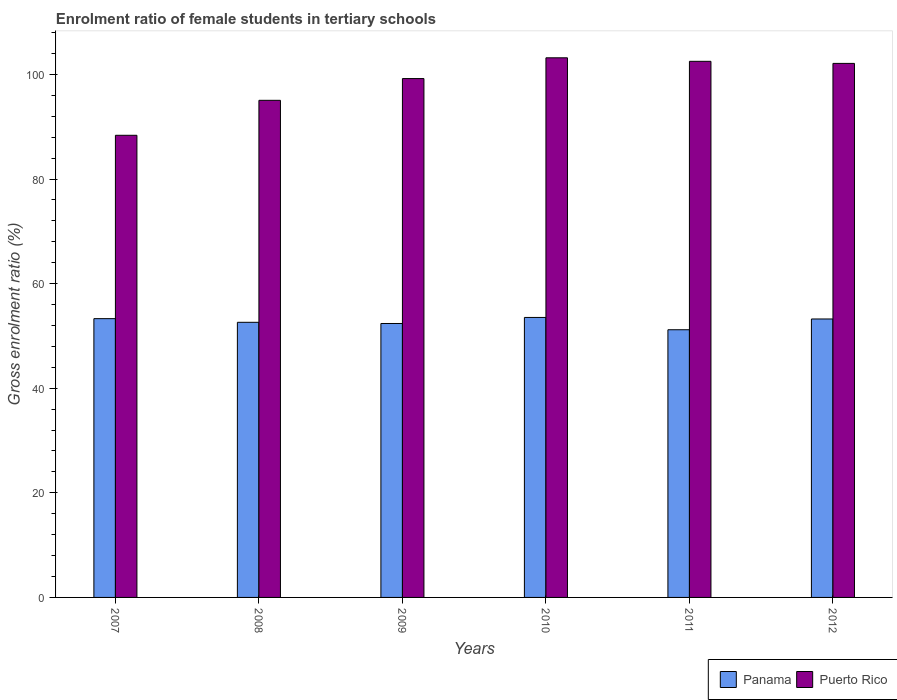How many different coloured bars are there?
Give a very brief answer. 2. Are the number of bars per tick equal to the number of legend labels?
Provide a short and direct response. Yes. How many bars are there on the 6th tick from the left?
Provide a succinct answer. 2. How many bars are there on the 2nd tick from the right?
Give a very brief answer. 2. In how many cases, is the number of bars for a given year not equal to the number of legend labels?
Your answer should be very brief. 0. What is the enrolment ratio of female students in tertiary schools in Panama in 2007?
Provide a short and direct response. 53.31. Across all years, what is the maximum enrolment ratio of female students in tertiary schools in Puerto Rico?
Offer a very short reply. 103.19. Across all years, what is the minimum enrolment ratio of female students in tertiary schools in Panama?
Your answer should be compact. 51.19. In which year was the enrolment ratio of female students in tertiary schools in Puerto Rico maximum?
Give a very brief answer. 2010. In which year was the enrolment ratio of female students in tertiary schools in Puerto Rico minimum?
Provide a succinct answer. 2007. What is the total enrolment ratio of female students in tertiary schools in Puerto Rico in the graph?
Your answer should be compact. 590.45. What is the difference between the enrolment ratio of female students in tertiary schools in Puerto Rico in 2011 and that in 2012?
Ensure brevity in your answer.  0.4. What is the difference between the enrolment ratio of female students in tertiary schools in Puerto Rico in 2011 and the enrolment ratio of female students in tertiary schools in Panama in 2009?
Your response must be concise. 50.13. What is the average enrolment ratio of female students in tertiary schools in Panama per year?
Give a very brief answer. 52.71. In the year 2007, what is the difference between the enrolment ratio of female students in tertiary schools in Puerto Rico and enrolment ratio of female students in tertiary schools in Panama?
Keep it short and to the point. 35.06. What is the ratio of the enrolment ratio of female students in tertiary schools in Panama in 2011 to that in 2012?
Keep it short and to the point. 0.96. What is the difference between the highest and the second highest enrolment ratio of female students in tertiary schools in Puerto Rico?
Your answer should be compact. 0.67. What is the difference between the highest and the lowest enrolment ratio of female students in tertiary schools in Panama?
Ensure brevity in your answer.  2.35. Is the sum of the enrolment ratio of female students in tertiary schools in Puerto Rico in 2007 and 2008 greater than the maximum enrolment ratio of female students in tertiary schools in Panama across all years?
Offer a very short reply. Yes. What does the 1st bar from the left in 2009 represents?
Make the answer very short. Panama. What does the 2nd bar from the right in 2010 represents?
Give a very brief answer. Panama. How many bars are there?
Your answer should be very brief. 12. Are all the bars in the graph horizontal?
Offer a very short reply. No. Are the values on the major ticks of Y-axis written in scientific E-notation?
Your answer should be compact. No. Where does the legend appear in the graph?
Provide a short and direct response. Bottom right. How are the legend labels stacked?
Provide a succinct answer. Horizontal. What is the title of the graph?
Offer a very short reply. Enrolment ratio of female students in tertiary schools. Does "Marshall Islands" appear as one of the legend labels in the graph?
Offer a terse response. No. What is the label or title of the X-axis?
Your answer should be compact. Years. What is the label or title of the Y-axis?
Provide a short and direct response. Gross enrolment ratio (%). What is the Gross enrolment ratio (%) of Panama in 2007?
Ensure brevity in your answer.  53.31. What is the Gross enrolment ratio (%) of Puerto Rico in 2007?
Make the answer very short. 88.37. What is the Gross enrolment ratio (%) of Panama in 2008?
Keep it short and to the point. 52.61. What is the Gross enrolment ratio (%) of Puerto Rico in 2008?
Keep it short and to the point. 95.06. What is the Gross enrolment ratio (%) in Panama in 2009?
Keep it short and to the point. 52.38. What is the Gross enrolment ratio (%) of Puerto Rico in 2009?
Make the answer very short. 99.21. What is the Gross enrolment ratio (%) in Panama in 2010?
Your answer should be compact. 53.54. What is the Gross enrolment ratio (%) of Puerto Rico in 2010?
Your response must be concise. 103.19. What is the Gross enrolment ratio (%) of Panama in 2011?
Your answer should be compact. 51.19. What is the Gross enrolment ratio (%) of Puerto Rico in 2011?
Make the answer very short. 102.51. What is the Gross enrolment ratio (%) of Panama in 2012?
Your answer should be very brief. 53.25. What is the Gross enrolment ratio (%) in Puerto Rico in 2012?
Offer a terse response. 102.11. Across all years, what is the maximum Gross enrolment ratio (%) of Panama?
Your response must be concise. 53.54. Across all years, what is the maximum Gross enrolment ratio (%) of Puerto Rico?
Offer a very short reply. 103.19. Across all years, what is the minimum Gross enrolment ratio (%) of Panama?
Ensure brevity in your answer.  51.19. Across all years, what is the minimum Gross enrolment ratio (%) in Puerto Rico?
Provide a succinct answer. 88.37. What is the total Gross enrolment ratio (%) in Panama in the graph?
Give a very brief answer. 316.27. What is the total Gross enrolment ratio (%) in Puerto Rico in the graph?
Offer a very short reply. 590.45. What is the difference between the Gross enrolment ratio (%) in Panama in 2007 and that in 2008?
Make the answer very short. 0.7. What is the difference between the Gross enrolment ratio (%) of Puerto Rico in 2007 and that in 2008?
Ensure brevity in your answer.  -6.69. What is the difference between the Gross enrolment ratio (%) of Panama in 2007 and that in 2009?
Your answer should be very brief. 0.92. What is the difference between the Gross enrolment ratio (%) of Puerto Rico in 2007 and that in 2009?
Make the answer very short. -10.85. What is the difference between the Gross enrolment ratio (%) in Panama in 2007 and that in 2010?
Provide a succinct answer. -0.23. What is the difference between the Gross enrolment ratio (%) in Puerto Rico in 2007 and that in 2010?
Offer a very short reply. -14.82. What is the difference between the Gross enrolment ratio (%) of Panama in 2007 and that in 2011?
Make the answer very short. 2.12. What is the difference between the Gross enrolment ratio (%) in Puerto Rico in 2007 and that in 2011?
Offer a very short reply. -14.14. What is the difference between the Gross enrolment ratio (%) of Panama in 2007 and that in 2012?
Provide a short and direct response. 0.06. What is the difference between the Gross enrolment ratio (%) of Puerto Rico in 2007 and that in 2012?
Give a very brief answer. -13.75. What is the difference between the Gross enrolment ratio (%) in Panama in 2008 and that in 2009?
Give a very brief answer. 0.23. What is the difference between the Gross enrolment ratio (%) in Puerto Rico in 2008 and that in 2009?
Your answer should be very brief. -4.16. What is the difference between the Gross enrolment ratio (%) of Panama in 2008 and that in 2010?
Ensure brevity in your answer.  -0.93. What is the difference between the Gross enrolment ratio (%) in Puerto Rico in 2008 and that in 2010?
Offer a very short reply. -8.13. What is the difference between the Gross enrolment ratio (%) in Panama in 2008 and that in 2011?
Give a very brief answer. 1.42. What is the difference between the Gross enrolment ratio (%) in Puerto Rico in 2008 and that in 2011?
Give a very brief answer. -7.46. What is the difference between the Gross enrolment ratio (%) in Panama in 2008 and that in 2012?
Provide a succinct answer. -0.64. What is the difference between the Gross enrolment ratio (%) in Puerto Rico in 2008 and that in 2012?
Give a very brief answer. -7.06. What is the difference between the Gross enrolment ratio (%) in Panama in 2009 and that in 2010?
Your response must be concise. -1.16. What is the difference between the Gross enrolment ratio (%) in Puerto Rico in 2009 and that in 2010?
Provide a succinct answer. -3.97. What is the difference between the Gross enrolment ratio (%) in Panama in 2009 and that in 2011?
Ensure brevity in your answer.  1.2. What is the difference between the Gross enrolment ratio (%) in Puerto Rico in 2009 and that in 2011?
Your answer should be compact. -3.3. What is the difference between the Gross enrolment ratio (%) of Panama in 2009 and that in 2012?
Your response must be concise. -0.86. What is the difference between the Gross enrolment ratio (%) in Puerto Rico in 2009 and that in 2012?
Your answer should be compact. -2.9. What is the difference between the Gross enrolment ratio (%) of Panama in 2010 and that in 2011?
Provide a short and direct response. 2.35. What is the difference between the Gross enrolment ratio (%) in Puerto Rico in 2010 and that in 2011?
Give a very brief answer. 0.67. What is the difference between the Gross enrolment ratio (%) in Panama in 2010 and that in 2012?
Keep it short and to the point. 0.29. What is the difference between the Gross enrolment ratio (%) in Puerto Rico in 2010 and that in 2012?
Make the answer very short. 1.07. What is the difference between the Gross enrolment ratio (%) in Panama in 2011 and that in 2012?
Provide a succinct answer. -2.06. What is the difference between the Gross enrolment ratio (%) in Puerto Rico in 2011 and that in 2012?
Your answer should be compact. 0.4. What is the difference between the Gross enrolment ratio (%) in Panama in 2007 and the Gross enrolment ratio (%) in Puerto Rico in 2008?
Your answer should be very brief. -41.75. What is the difference between the Gross enrolment ratio (%) in Panama in 2007 and the Gross enrolment ratio (%) in Puerto Rico in 2009?
Ensure brevity in your answer.  -45.91. What is the difference between the Gross enrolment ratio (%) in Panama in 2007 and the Gross enrolment ratio (%) in Puerto Rico in 2010?
Your answer should be compact. -49.88. What is the difference between the Gross enrolment ratio (%) of Panama in 2007 and the Gross enrolment ratio (%) of Puerto Rico in 2011?
Your answer should be very brief. -49.21. What is the difference between the Gross enrolment ratio (%) of Panama in 2007 and the Gross enrolment ratio (%) of Puerto Rico in 2012?
Offer a very short reply. -48.81. What is the difference between the Gross enrolment ratio (%) in Panama in 2008 and the Gross enrolment ratio (%) in Puerto Rico in 2009?
Offer a very short reply. -46.6. What is the difference between the Gross enrolment ratio (%) of Panama in 2008 and the Gross enrolment ratio (%) of Puerto Rico in 2010?
Offer a terse response. -50.58. What is the difference between the Gross enrolment ratio (%) in Panama in 2008 and the Gross enrolment ratio (%) in Puerto Rico in 2011?
Your answer should be very brief. -49.9. What is the difference between the Gross enrolment ratio (%) of Panama in 2008 and the Gross enrolment ratio (%) of Puerto Rico in 2012?
Ensure brevity in your answer.  -49.5. What is the difference between the Gross enrolment ratio (%) in Panama in 2009 and the Gross enrolment ratio (%) in Puerto Rico in 2010?
Your answer should be very brief. -50.8. What is the difference between the Gross enrolment ratio (%) of Panama in 2009 and the Gross enrolment ratio (%) of Puerto Rico in 2011?
Provide a succinct answer. -50.13. What is the difference between the Gross enrolment ratio (%) of Panama in 2009 and the Gross enrolment ratio (%) of Puerto Rico in 2012?
Offer a terse response. -49.73. What is the difference between the Gross enrolment ratio (%) of Panama in 2010 and the Gross enrolment ratio (%) of Puerto Rico in 2011?
Provide a succinct answer. -48.98. What is the difference between the Gross enrolment ratio (%) of Panama in 2010 and the Gross enrolment ratio (%) of Puerto Rico in 2012?
Provide a succinct answer. -48.58. What is the difference between the Gross enrolment ratio (%) of Panama in 2011 and the Gross enrolment ratio (%) of Puerto Rico in 2012?
Give a very brief answer. -50.93. What is the average Gross enrolment ratio (%) in Panama per year?
Provide a succinct answer. 52.71. What is the average Gross enrolment ratio (%) of Puerto Rico per year?
Keep it short and to the point. 98.41. In the year 2007, what is the difference between the Gross enrolment ratio (%) in Panama and Gross enrolment ratio (%) in Puerto Rico?
Offer a very short reply. -35.06. In the year 2008, what is the difference between the Gross enrolment ratio (%) of Panama and Gross enrolment ratio (%) of Puerto Rico?
Provide a succinct answer. -42.45. In the year 2009, what is the difference between the Gross enrolment ratio (%) of Panama and Gross enrolment ratio (%) of Puerto Rico?
Offer a very short reply. -46.83. In the year 2010, what is the difference between the Gross enrolment ratio (%) in Panama and Gross enrolment ratio (%) in Puerto Rico?
Offer a terse response. -49.65. In the year 2011, what is the difference between the Gross enrolment ratio (%) of Panama and Gross enrolment ratio (%) of Puerto Rico?
Your answer should be very brief. -51.33. In the year 2012, what is the difference between the Gross enrolment ratio (%) in Panama and Gross enrolment ratio (%) in Puerto Rico?
Provide a short and direct response. -48.87. What is the ratio of the Gross enrolment ratio (%) of Panama in 2007 to that in 2008?
Offer a very short reply. 1.01. What is the ratio of the Gross enrolment ratio (%) of Puerto Rico in 2007 to that in 2008?
Provide a short and direct response. 0.93. What is the ratio of the Gross enrolment ratio (%) of Panama in 2007 to that in 2009?
Your answer should be compact. 1.02. What is the ratio of the Gross enrolment ratio (%) of Puerto Rico in 2007 to that in 2009?
Make the answer very short. 0.89. What is the ratio of the Gross enrolment ratio (%) in Panama in 2007 to that in 2010?
Provide a succinct answer. 1. What is the ratio of the Gross enrolment ratio (%) in Puerto Rico in 2007 to that in 2010?
Your answer should be very brief. 0.86. What is the ratio of the Gross enrolment ratio (%) in Panama in 2007 to that in 2011?
Offer a terse response. 1.04. What is the ratio of the Gross enrolment ratio (%) in Puerto Rico in 2007 to that in 2011?
Provide a short and direct response. 0.86. What is the ratio of the Gross enrolment ratio (%) in Puerto Rico in 2007 to that in 2012?
Provide a short and direct response. 0.87. What is the ratio of the Gross enrolment ratio (%) in Puerto Rico in 2008 to that in 2009?
Offer a very short reply. 0.96. What is the ratio of the Gross enrolment ratio (%) in Panama in 2008 to that in 2010?
Make the answer very short. 0.98. What is the ratio of the Gross enrolment ratio (%) in Puerto Rico in 2008 to that in 2010?
Make the answer very short. 0.92. What is the ratio of the Gross enrolment ratio (%) in Panama in 2008 to that in 2011?
Ensure brevity in your answer.  1.03. What is the ratio of the Gross enrolment ratio (%) in Puerto Rico in 2008 to that in 2011?
Offer a terse response. 0.93. What is the ratio of the Gross enrolment ratio (%) of Panama in 2008 to that in 2012?
Your answer should be very brief. 0.99. What is the ratio of the Gross enrolment ratio (%) of Puerto Rico in 2008 to that in 2012?
Provide a succinct answer. 0.93. What is the ratio of the Gross enrolment ratio (%) of Panama in 2009 to that in 2010?
Offer a very short reply. 0.98. What is the ratio of the Gross enrolment ratio (%) of Puerto Rico in 2009 to that in 2010?
Give a very brief answer. 0.96. What is the ratio of the Gross enrolment ratio (%) of Panama in 2009 to that in 2011?
Make the answer very short. 1.02. What is the ratio of the Gross enrolment ratio (%) in Puerto Rico in 2009 to that in 2011?
Your answer should be very brief. 0.97. What is the ratio of the Gross enrolment ratio (%) of Panama in 2009 to that in 2012?
Your response must be concise. 0.98. What is the ratio of the Gross enrolment ratio (%) of Puerto Rico in 2009 to that in 2012?
Your answer should be very brief. 0.97. What is the ratio of the Gross enrolment ratio (%) in Panama in 2010 to that in 2011?
Your answer should be compact. 1.05. What is the ratio of the Gross enrolment ratio (%) of Puerto Rico in 2010 to that in 2011?
Your answer should be compact. 1.01. What is the ratio of the Gross enrolment ratio (%) in Panama in 2010 to that in 2012?
Your answer should be very brief. 1.01. What is the ratio of the Gross enrolment ratio (%) of Puerto Rico in 2010 to that in 2012?
Provide a succinct answer. 1.01. What is the ratio of the Gross enrolment ratio (%) in Panama in 2011 to that in 2012?
Ensure brevity in your answer.  0.96. What is the difference between the highest and the second highest Gross enrolment ratio (%) in Panama?
Your answer should be very brief. 0.23. What is the difference between the highest and the second highest Gross enrolment ratio (%) in Puerto Rico?
Ensure brevity in your answer.  0.67. What is the difference between the highest and the lowest Gross enrolment ratio (%) of Panama?
Your response must be concise. 2.35. What is the difference between the highest and the lowest Gross enrolment ratio (%) of Puerto Rico?
Offer a terse response. 14.82. 